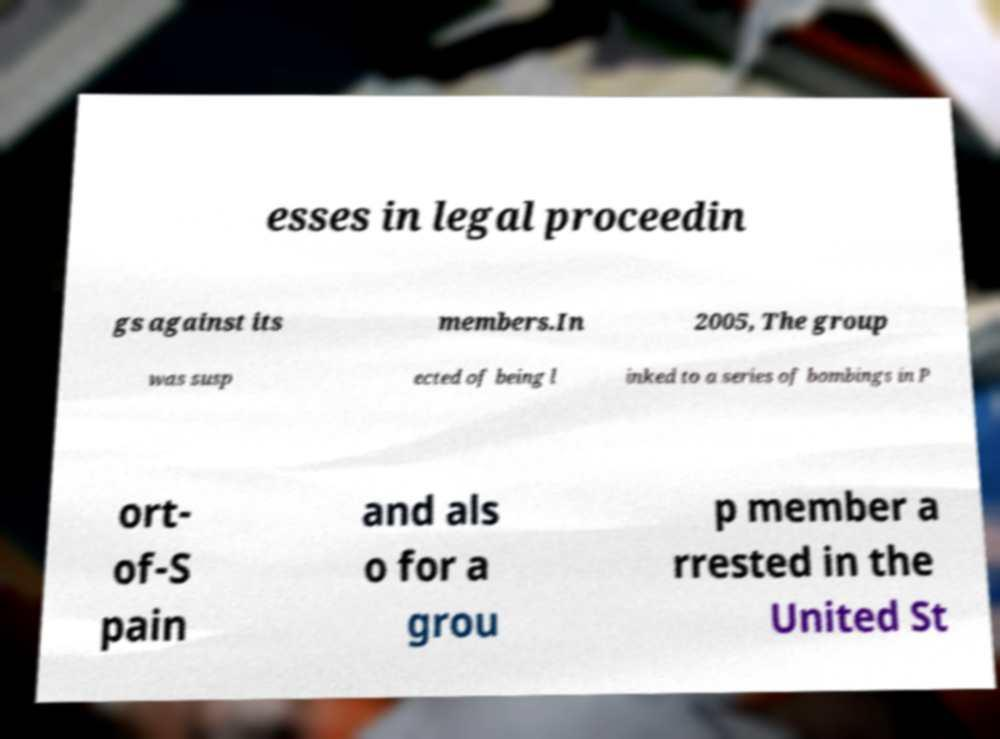For documentation purposes, I need the text within this image transcribed. Could you provide that? esses in legal proceedin gs against its members.In 2005, The group was susp ected of being l inked to a series of bombings in P ort- of-S pain and als o for a grou p member a rrested in the United St 